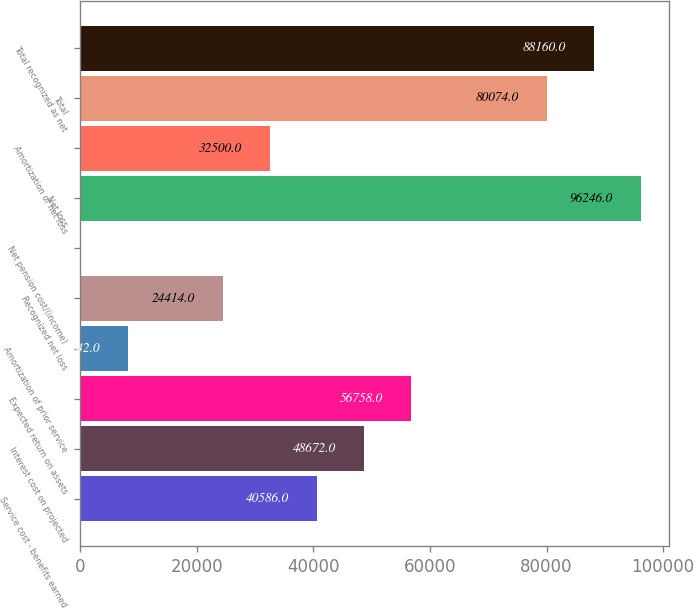<chart> <loc_0><loc_0><loc_500><loc_500><bar_chart><fcel>Service cost - benefits earned<fcel>Interest cost on projected<fcel>Expected return on assets<fcel>Amortization of prior service<fcel>Recognized net loss<fcel>Net pension cost/(income)<fcel>Net loss<fcel>Amortization of net loss<fcel>Total<fcel>Total recognized as net<nl><fcel>40586<fcel>48672<fcel>56758<fcel>8242<fcel>24414<fcel>156<fcel>96246<fcel>32500<fcel>80074<fcel>88160<nl></chart> 